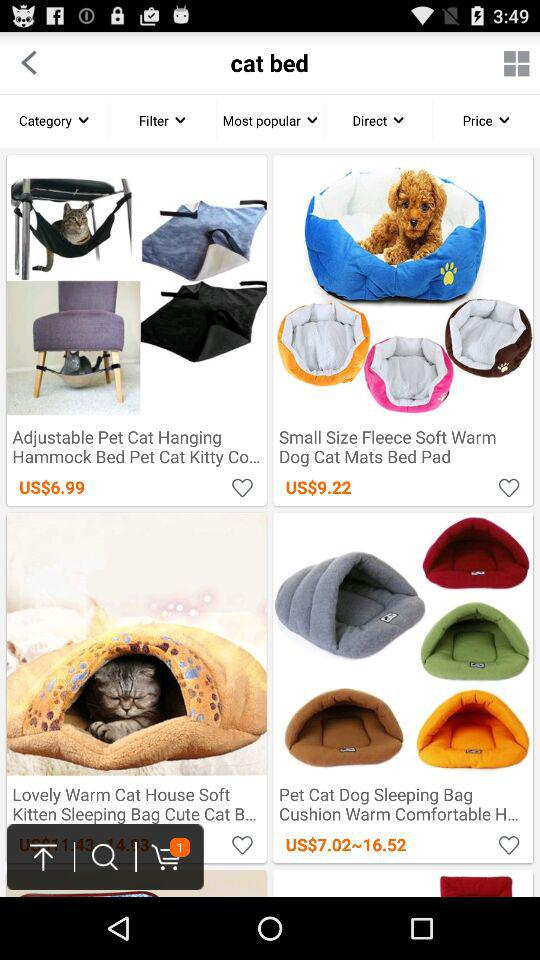How much is the price shown for "Adjustable Pet Cat Hanging Hammock Bed Pet Cat Kitty"? The price shown for "Adjustable Pet Cat Hanging Hammock Bed Pet Cat Kitty" is 6.99 United States dollars. 